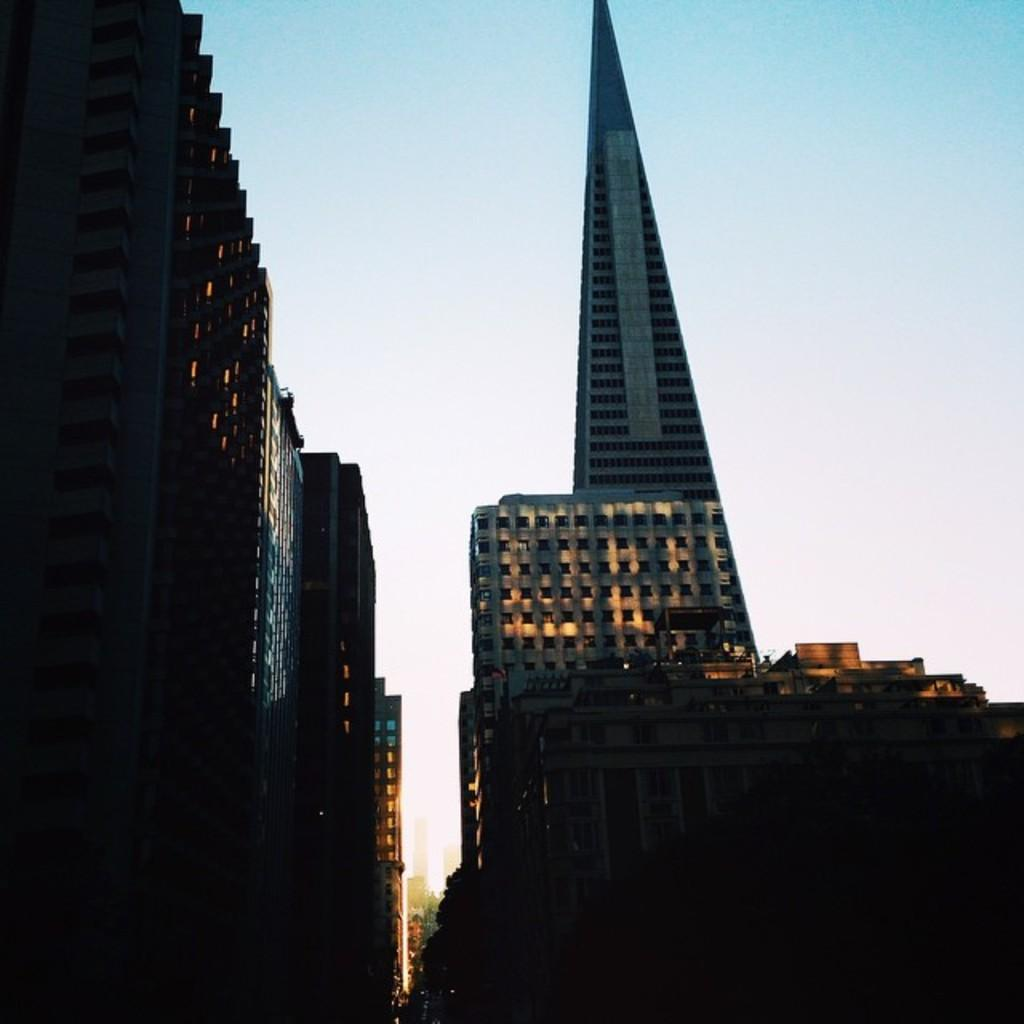What type of structures are located in the left corner of the image? There are buildings in the left corner of the image. What can be seen in the right corner of the image? There is a tower building in the right corner of the image. Are there any other buildings near the tower building? Yes, there are additional buildings beside the tower building. What type of rake is being used by the maid in the image? There is no rake or maid present in the image. How does the mind of the person who took the image influence the composition of the image? The image itself does not provide any information about the mind of the person who took it, so we cannot determine how it influenced the composition. 